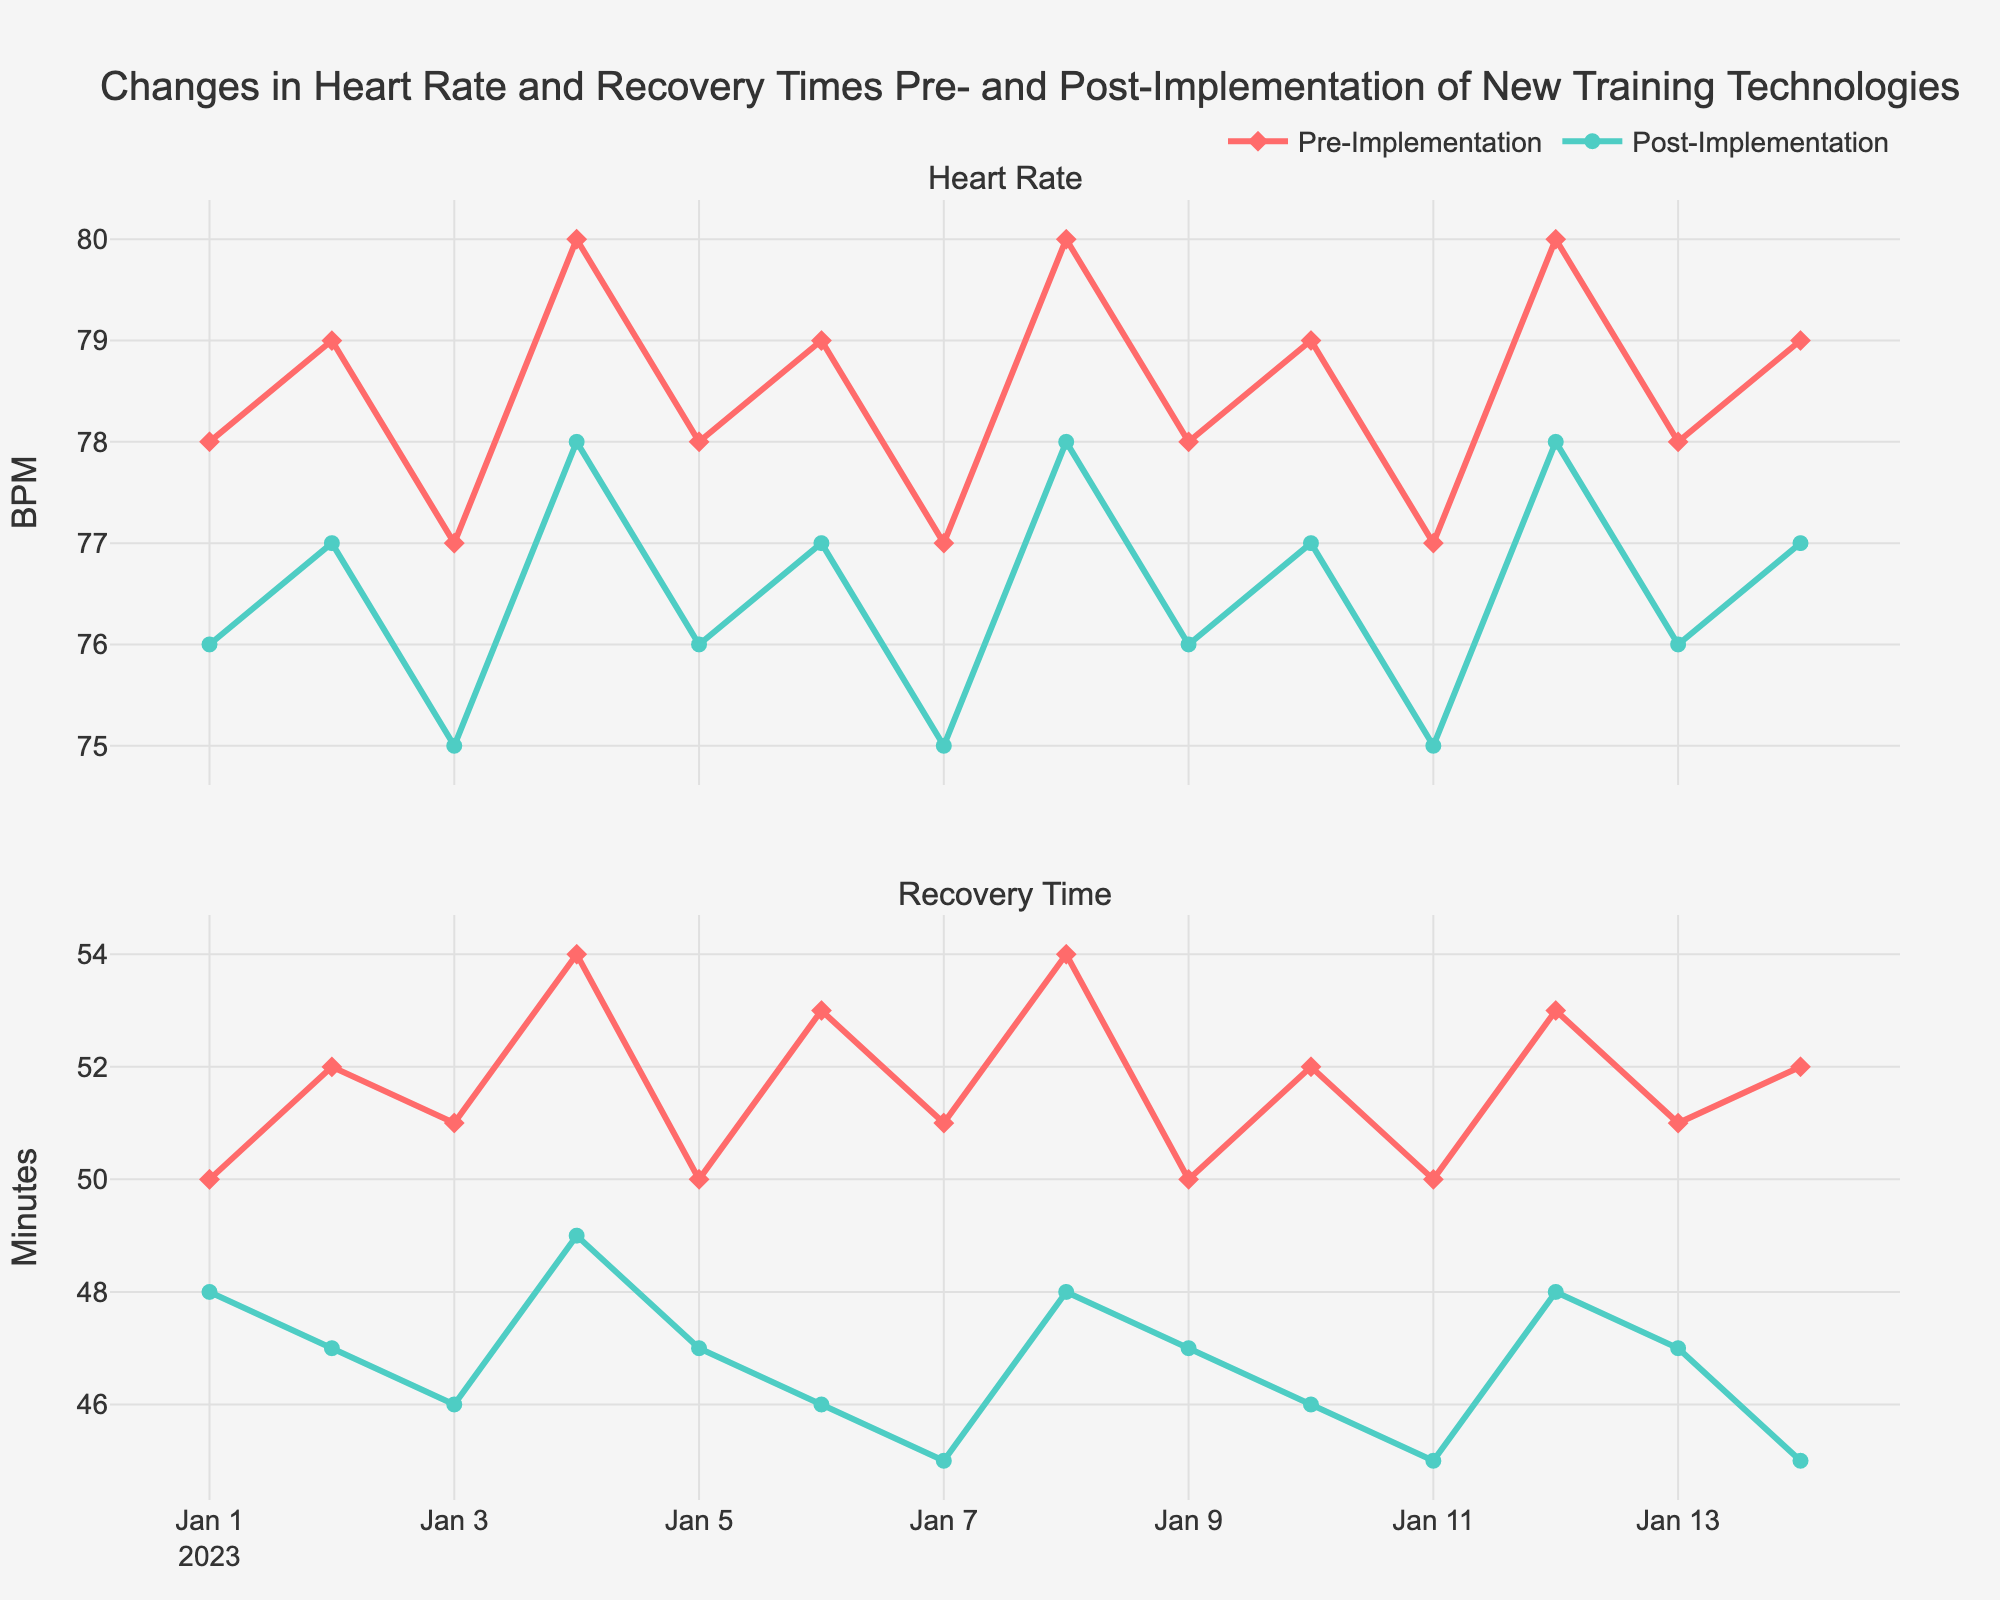What is the title of the figure? The title is usually displayed at the top of the figure. In this case, the title is "Changes in Heart Rate and Recovery Times Pre- and Post-Implementation of New Training Technologies."
Answer: Changes in Heart Rate and Recovery Times Pre- and Post-Implementation of New Training Technologies What are the colors used to represent pre- and post-implementation data? The pre-implementation data is represented by warmer, reddish colors, while the post-implementation data is represented by cooler, greenish-blue colors.
Answer: Reddish for pre-implementation, greenish-blue for post-implementation What is the heart rate on 2023-01-04 pre-implementation? Locate the data point on the heart rate plot for the date 2023-01-04. The heart rate on this date pre-implementation is 80 BPM.
Answer: 80 BPM How does the trend in heart rate compare between pre- and post-implementation over the given period? Examine the lines connecting the data points for both pre- and post-implementation heart rates. While both trends vary slightly, overall, the post-implementation heart rate is slightly lower on most days compared to pre-implementation.
Answer: Post-implementation heart rate is generally lower What is the difference in recovery time on 2023-01-07 between pre- and post-implementation? Find the recovery times on 2023-01-07 for both pre- and post-implementation. The pre-implementation recovery time is 51 minutes, while the post-implementation recovery time is 45 minutes. The difference is 51 - 45.
Answer: 6 minutes Which date shows the highest pre-implementation recovery time and what is this value? Identify the maximum value in the pre-implementation recovery time series. The highest value is 54 minutes on dates 2023-01-04 and 2023-01-08.
Answer: 54 minutes on 2023-01-04 and 2023-01-08 What is the average post-implementation heart rate over the two-week period? Sum the post-implementation heart rates and divide by the number of data points (14 days). (76+77+75+78+76+77+75+78+76+77+75+78+76+77) / 14 = 76.57 BPM.
Answer: 76.57 BPM By how much did the recovery time improve on average after implementing the new training technologies? Calculate the difference in average recovery times pre- and post-implementation. (Pre: (50+52+51+54+50+53+51+54+50+52+50+53+51+52)/14 = 51.57 minutes, Post: (48+47+46+49+47+46+45+48+47+46+45+48+47+45)/14 = 46.93 minutes; Improvement: 51.57 - 46.93).
Answer: 4.64 minutes Do recovery times always decrease post-implementation compared to pre-implementation for each day? Compare the daily recovery times pre- and post-implementation. Examine if every post-implementation recovery time is less than or equal to the corresponding pre-implementation value. Yes, it occurs for each day.
Answer: Yes 